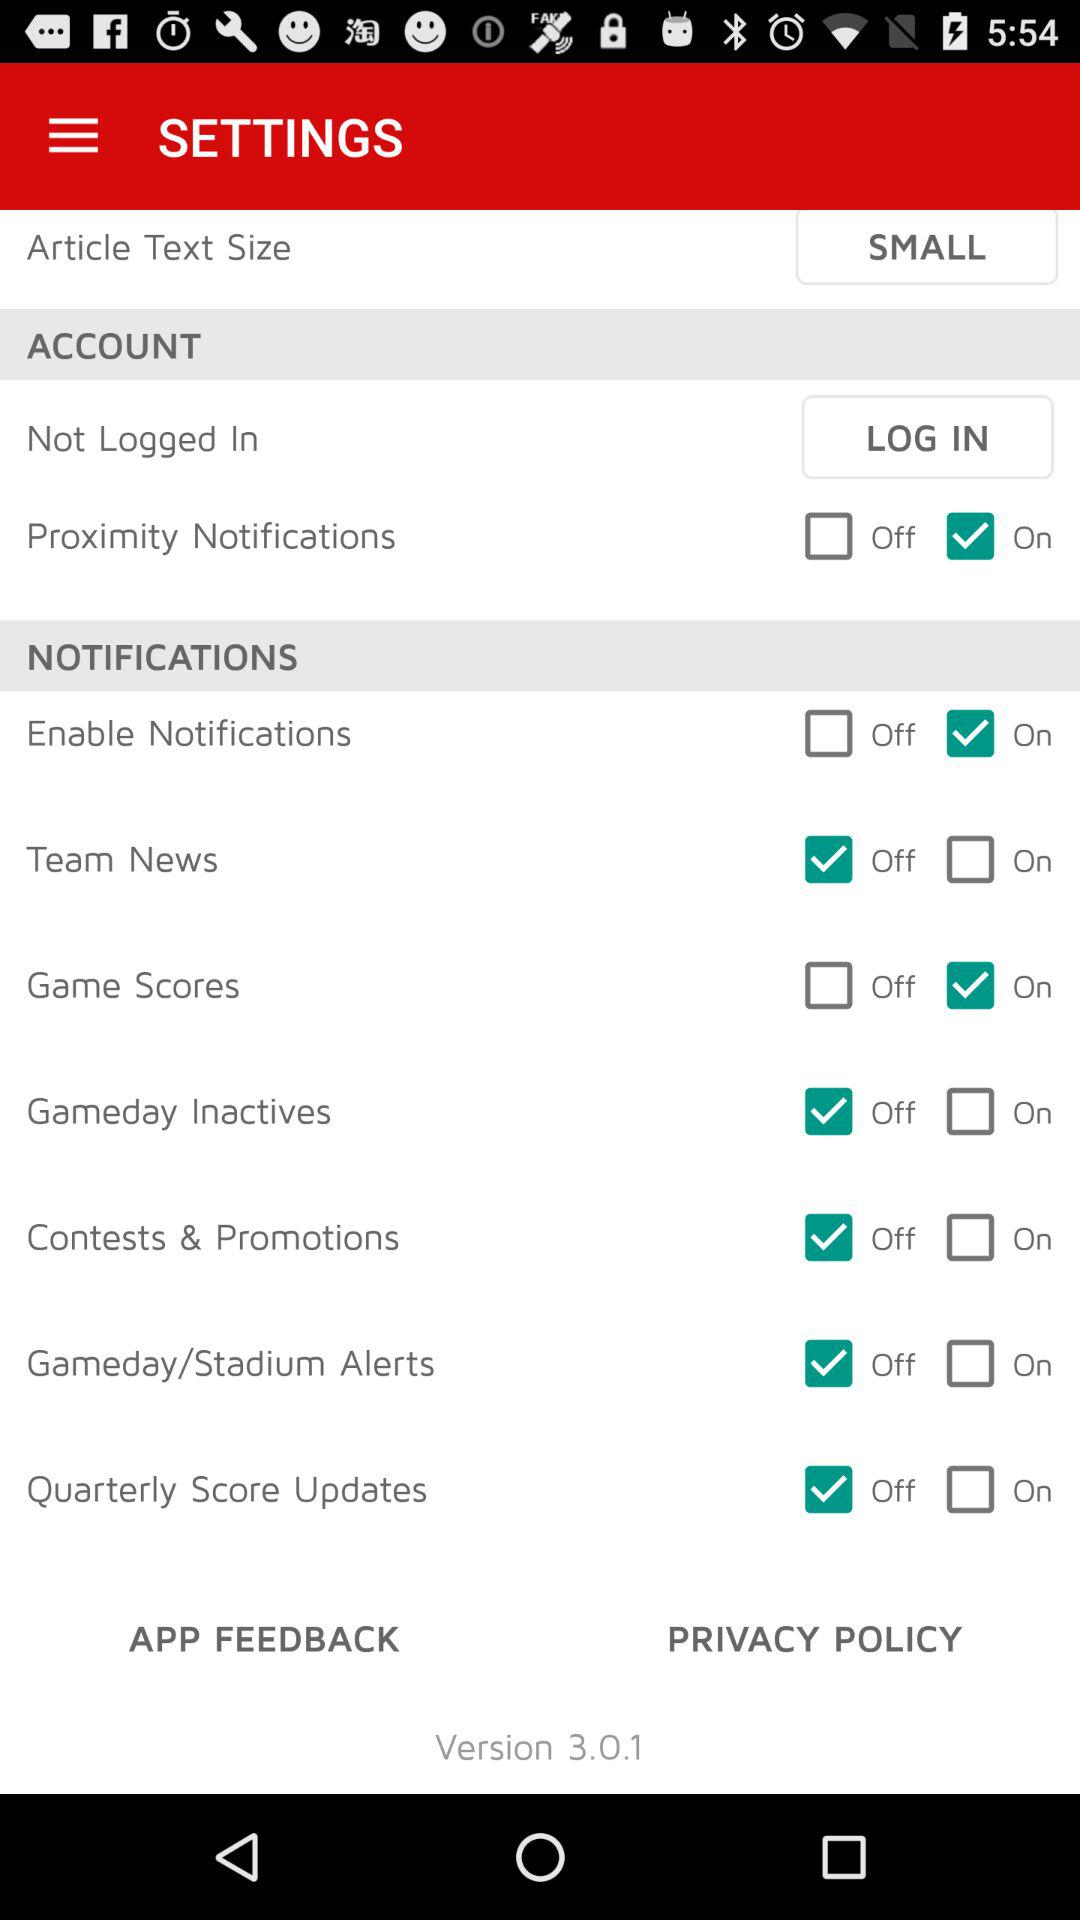What is the current status of "Game Scores"? The current status of "Game Scores" is "on". 